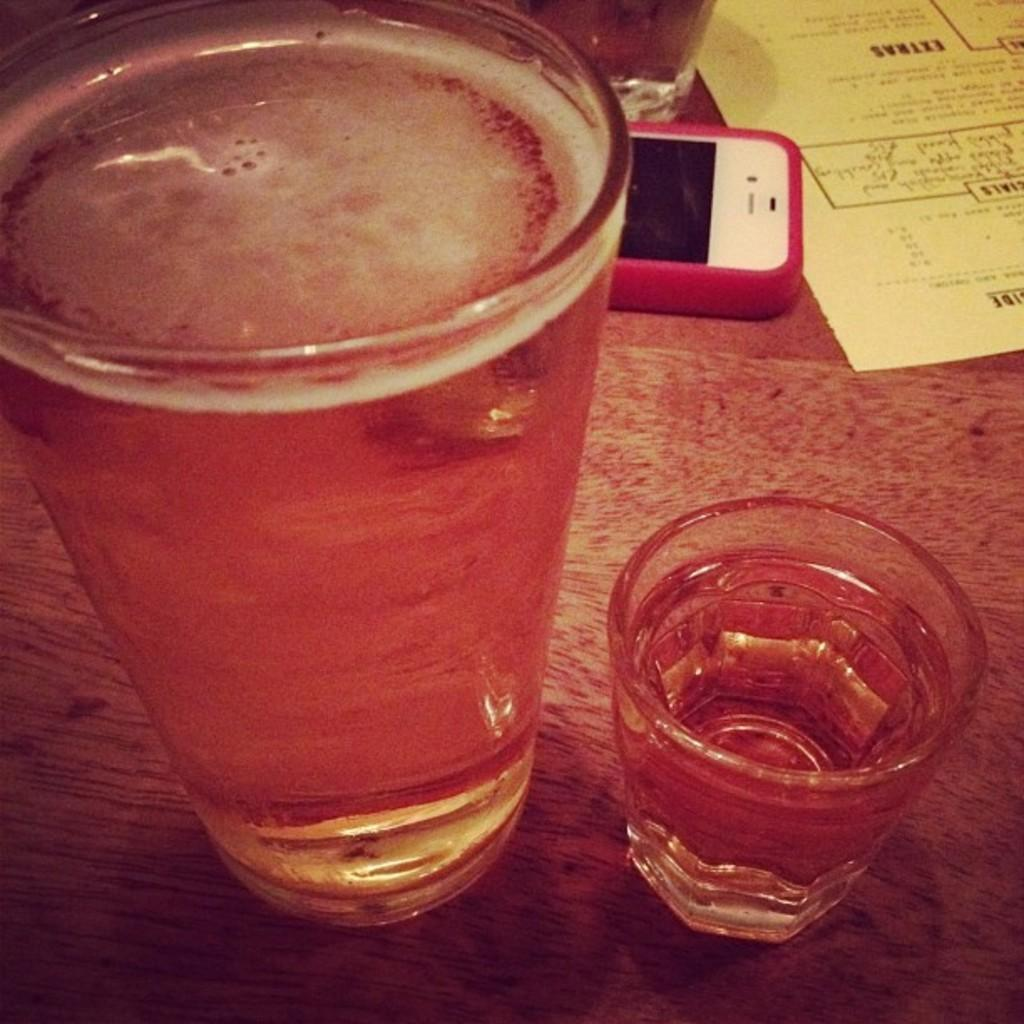What is in the glasses that are visible in the image? There are two glasses full of juice in the image. What is located behind the glasses? A mobile and a paper are present behind the glasses. What type of voice can be heard coming from the tree in the image? There is no tree present in the image, so it is not possible to determine what, if any, voice might be heard. 